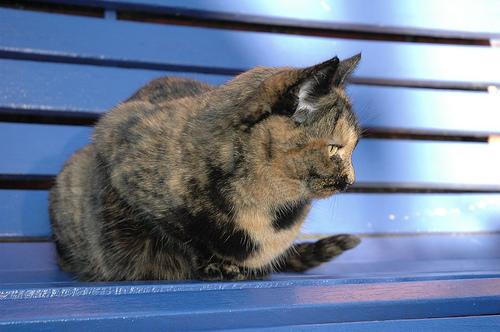Is the cat sleeping?
Write a very short answer. No. What is the thing the cat is sitting on made of?
Write a very short answer. Wood. Is this cat white?
Answer briefly. No. 